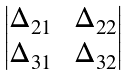Convert formula to latex. <formula><loc_0><loc_0><loc_500><loc_500>\begin{vmatrix} \Delta _ { 2 1 } & \, \Delta _ { 2 2 } \\ \Delta _ { 3 1 } & \, \Delta _ { 3 2 } \end{vmatrix}</formula> 